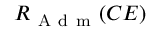Convert formula to latex. <formula><loc_0><loc_0><loc_500><loc_500>R _ { A d m } ( C E )</formula> 